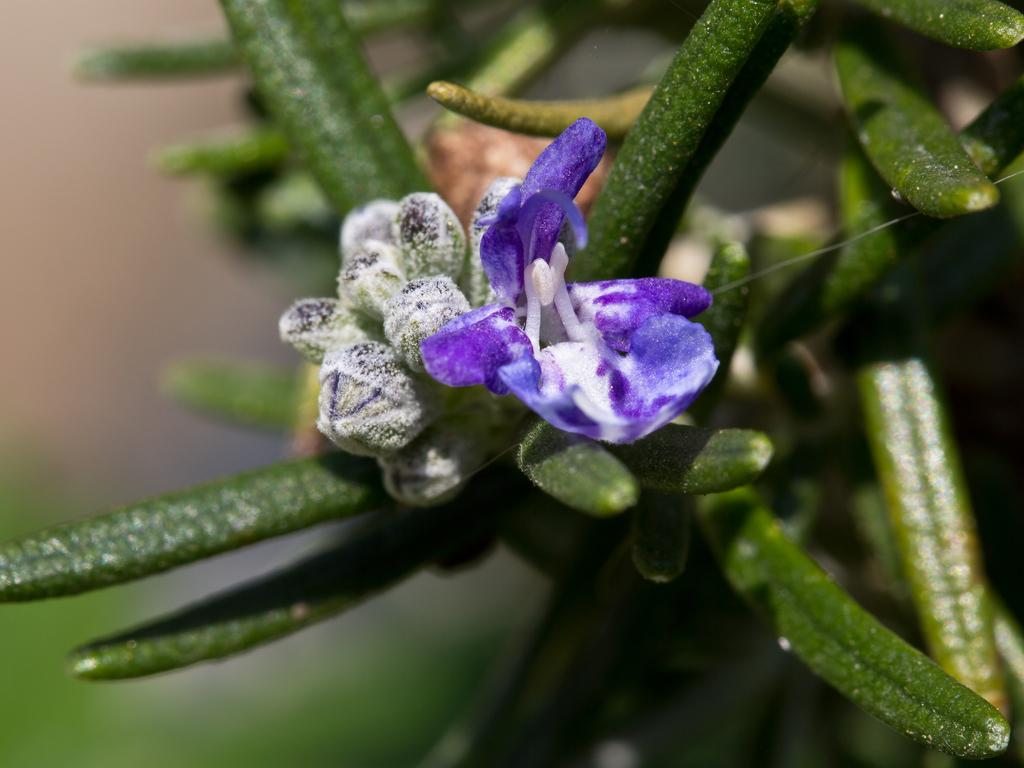What is present in the image? There is a plant in the image. What is unique about the flowers on the plant? The plant has blue flowers. What is the growth stage of the plant? The plant has buds. How would you describe the background of the image? The background of the image is blurred. What note is the plant playing in the image? There is no note or music being played in the image; it features a plant with blue flowers and buds. What school is the plant attending in the image? The image does not depict a school or any educational setting; it features a plant with blue flowers and buds. 